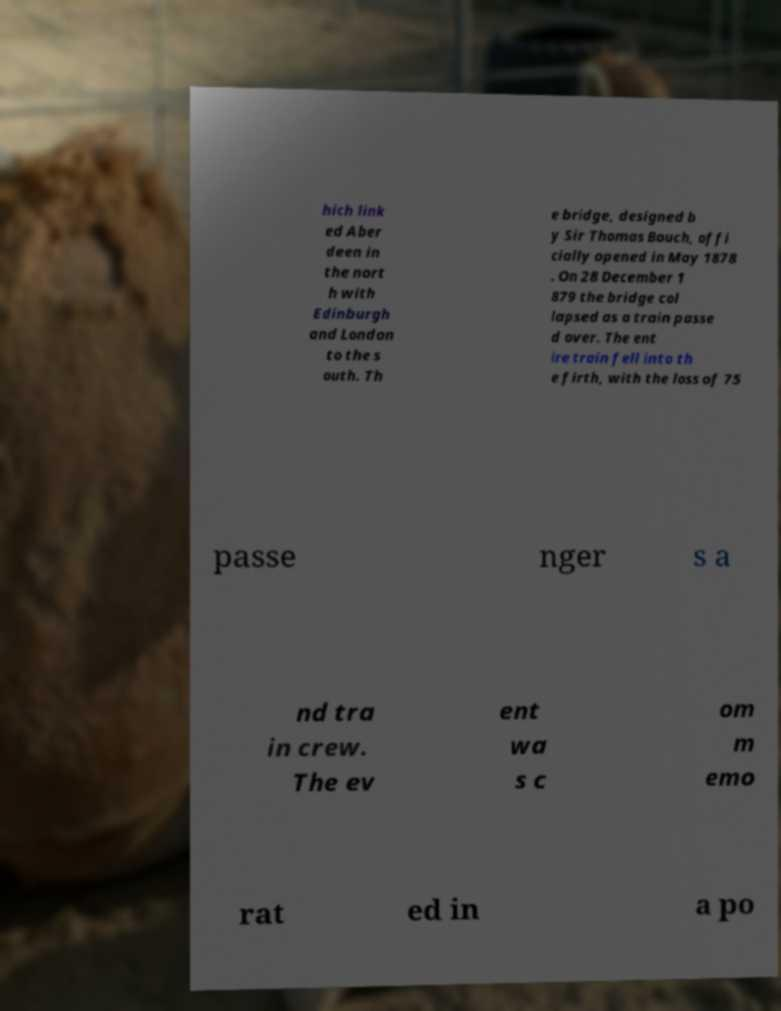Can you accurately transcribe the text from the provided image for me? hich link ed Aber deen in the nort h with Edinburgh and London to the s outh. Th e bridge, designed b y Sir Thomas Bouch, offi cially opened in May 1878 . On 28 December 1 879 the bridge col lapsed as a train passe d over. The ent ire train fell into th e firth, with the loss of 75 passe nger s a nd tra in crew. The ev ent wa s c om m emo rat ed in a po 